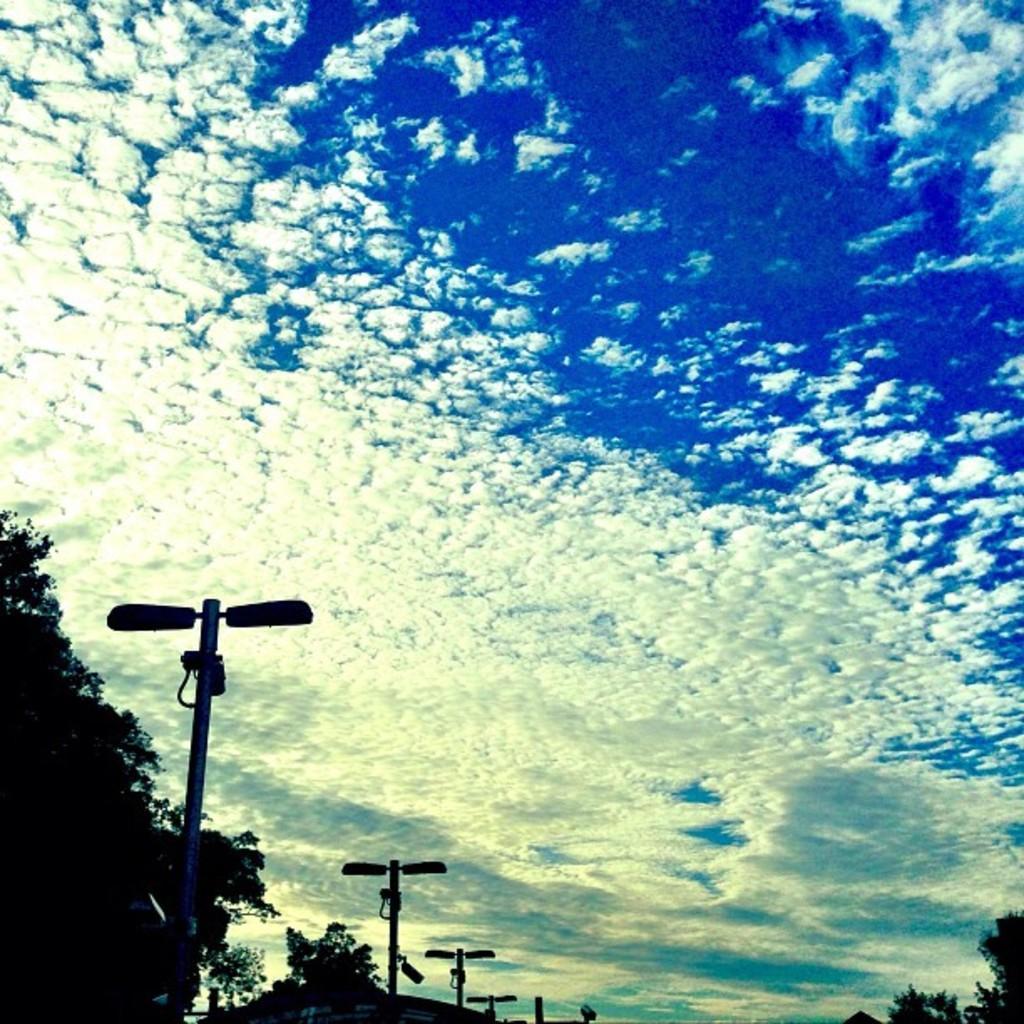Could you give a brief overview of what you see in this image? This picture is clicked outside. In the foreground we can see the street lights, poles and trees. In the background we can see the sky which is full of clouds. 